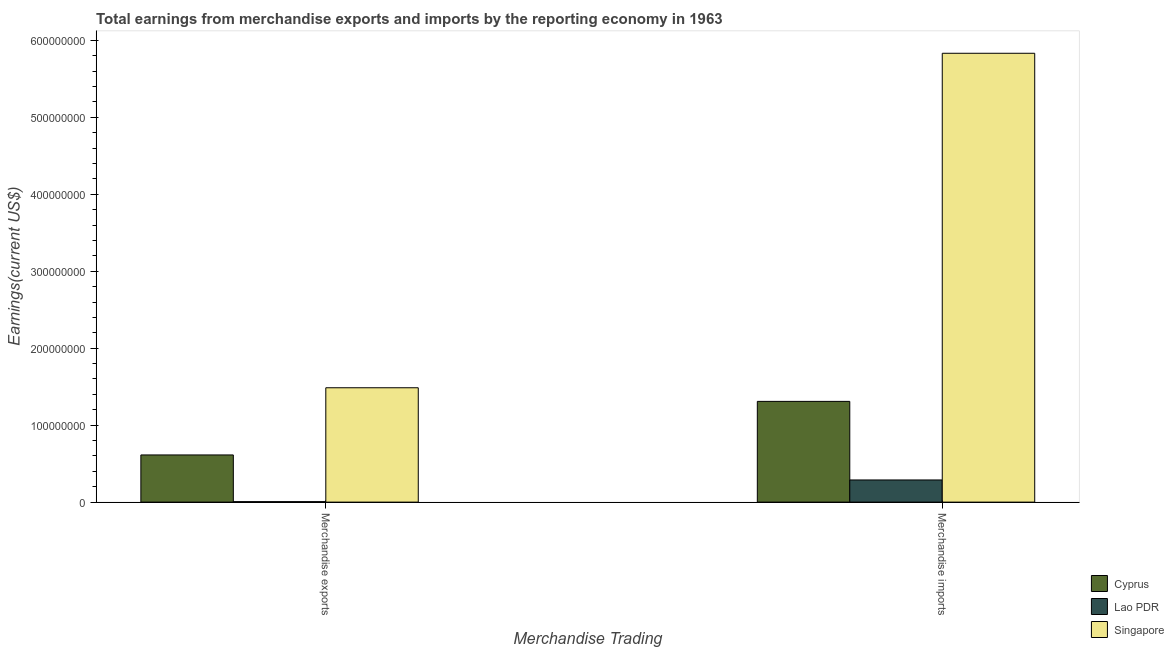How many groups of bars are there?
Provide a short and direct response. 2. How many bars are there on the 2nd tick from the left?
Make the answer very short. 3. What is the earnings from merchandise imports in Lao PDR?
Your answer should be very brief. 2.88e+07. Across all countries, what is the maximum earnings from merchandise exports?
Give a very brief answer. 1.49e+08. Across all countries, what is the minimum earnings from merchandise exports?
Your response must be concise. 5.90e+05. In which country was the earnings from merchandise exports maximum?
Your response must be concise. Singapore. In which country was the earnings from merchandise exports minimum?
Give a very brief answer. Lao PDR. What is the total earnings from merchandise imports in the graph?
Make the answer very short. 7.43e+08. What is the difference between the earnings from merchandise exports in Cyprus and that in Lao PDR?
Offer a very short reply. 6.07e+07. What is the difference between the earnings from merchandise exports in Lao PDR and the earnings from merchandise imports in Singapore?
Your answer should be compact. -5.83e+08. What is the average earnings from merchandise imports per country?
Provide a short and direct response. 2.48e+08. What is the difference between the earnings from merchandise exports and earnings from merchandise imports in Cyprus?
Your answer should be very brief. -6.96e+07. In how many countries, is the earnings from merchandise imports greater than 280000000 US$?
Give a very brief answer. 1. What is the ratio of the earnings from merchandise exports in Lao PDR to that in Singapore?
Offer a very short reply. 0. Is the earnings from merchandise imports in Lao PDR less than that in Singapore?
Give a very brief answer. Yes. In how many countries, is the earnings from merchandise imports greater than the average earnings from merchandise imports taken over all countries?
Offer a terse response. 1. What does the 2nd bar from the left in Merchandise imports represents?
Your answer should be compact. Lao PDR. What does the 2nd bar from the right in Merchandise exports represents?
Make the answer very short. Lao PDR. How many bars are there?
Provide a short and direct response. 6. Are all the bars in the graph horizontal?
Keep it short and to the point. No. What is the difference between two consecutive major ticks on the Y-axis?
Your response must be concise. 1.00e+08. Are the values on the major ticks of Y-axis written in scientific E-notation?
Offer a very short reply. No. Does the graph contain any zero values?
Make the answer very short. No. Does the graph contain grids?
Offer a very short reply. No. Where does the legend appear in the graph?
Your response must be concise. Bottom right. How many legend labels are there?
Your answer should be compact. 3. How are the legend labels stacked?
Provide a short and direct response. Vertical. What is the title of the graph?
Offer a very short reply. Total earnings from merchandise exports and imports by the reporting economy in 1963. Does "Cameroon" appear as one of the legend labels in the graph?
Offer a very short reply. No. What is the label or title of the X-axis?
Make the answer very short. Merchandise Trading. What is the label or title of the Y-axis?
Provide a succinct answer. Earnings(current US$). What is the Earnings(current US$) in Cyprus in Merchandise exports?
Your answer should be very brief. 6.13e+07. What is the Earnings(current US$) in Lao PDR in Merchandise exports?
Your answer should be compact. 5.90e+05. What is the Earnings(current US$) of Singapore in Merchandise exports?
Your response must be concise. 1.49e+08. What is the Earnings(current US$) in Cyprus in Merchandise imports?
Provide a succinct answer. 1.31e+08. What is the Earnings(current US$) in Lao PDR in Merchandise imports?
Keep it short and to the point. 2.88e+07. What is the Earnings(current US$) of Singapore in Merchandise imports?
Give a very brief answer. 5.83e+08. Across all Merchandise Trading, what is the maximum Earnings(current US$) in Cyprus?
Give a very brief answer. 1.31e+08. Across all Merchandise Trading, what is the maximum Earnings(current US$) of Lao PDR?
Provide a short and direct response. 2.88e+07. Across all Merchandise Trading, what is the maximum Earnings(current US$) of Singapore?
Offer a terse response. 5.83e+08. Across all Merchandise Trading, what is the minimum Earnings(current US$) in Cyprus?
Provide a succinct answer. 6.13e+07. Across all Merchandise Trading, what is the minimum Earnings(current US$) in Lao PDR?
Your response must be concise. 5.90e+05. Across all Merchandise Trading, what is the minimum Earnings(current US$) of Singapore?
Make the answer very short. 1.49e+08. What is the total Earnings(current US$) in Cyprus in the graph?
Ensure brevity in your answer.  1.92e+08. What is the total Earnings(current US$) of Lao PDR in the graph?
Give a very brief answer. 2.94e+07. What is the total Earnings(current US$) in Singapore in the graph?
Make the answer very short. 7.32e+08. What is the difference between the Earnings(current US$) of Cyprus in Merchandise exports and that in Merchandise imports?
Provide a succinct answer. -6.96e+07. What is the difference between the Earnings(current US$) of Lao PDR in Merchandise exports and that in Merchandise imports?
Your answer should be very brief. -2.82e+07. What is the difference between the Earnings(current US$) in Singapore in Merchandise exports and that in Merchandise imports?
Your answer should be compact. -4.35e+08. What is the difference between the Earnings(current US$) in Cyprus in Merchandise exports and the Earnings(current US$) in Lao PDR in Merchandise imports?
Ensure brevity in your answer.  3.25e+07. What is the difference between the Earnings(current US$) in Cyprus in Merchandise exports and the Earnings(current US$) in Singapore in Merchandise imports?
Offer a terse response. -5.22e+08. What is the difference between the Earnings(current US$) of Lao PDR in Merchandise exports and the Earnings(current US$) of Singapore in Merchandise imports?
Your answer should be compact. -5.83e+08. What is the average Earnings(current US$) in Cyprus per Merchandise Trading?
Your response must be concise. 9.61e+07. What is the average Earnings(current US$) in Lao PDR per Merchandise Trading?
Your response must be concise. 1.47e+07. What is the average Earnings(current US$) in Singapore per Merchandise Trading?
Keep it short and to the point. 3.66e+08. What is the difference between the Earnings(current US$) in Cyprus and Earnings(current US$) in Lao PDR in Merchandise exports?
Offer a terse response. 6.07e+07. What is the difference between the Earnings(current US$) of Cyprus and Earnings(current US$) of Singapore in Merchandise exports?
Provide a succinct answer. -8.73e+07. What is the difference between the Earnings(current US$) in Lao PDR and Earnings(current US$) in Singapore in Merchandise exports?
Make the answer very short. -1.48e+08. What is the difference between the Earnings(current US$) of Cyprus and Earnings(current US$) of Lao PDR in Merchandise imports?
Provide a short and direct response. 1.02e+08. What is the difference between the Earnings(current US$) in Cyprus and Earnings(current US$) in Singapore in Merchandise imports?
Ensure brevity in your answer.  -4.52e+08. What is the difference between the Earnings(current US$) of Lao PDR and Earnings(current US$) of Singapore in Merchandise imports?
Your answer should be very brief. -5.54e+08. What is the ratio of the Earnings(current US$) in Cyprus in Merchandise exports to that in Merchandise imports?
Offer a terse response. 0.47. What is the ratio of the Earnings(current US$) in Lao PDR in Merchandise exports to that in Merchandise imports?
Provide a succinct answer. 0.02. What is the ratio of the Earnings(current US$) in Singapore in Merchandise exports to that in Merchandise imports?
Your answer should be very brief. 0.25. What is the difference between the highest and the second highest Earnings(current US$) in Cyprus?
Make the answer very short. 6.96e+07. What is the difference between the highest and the second highest Earnings(current US$) of Lao PDR?
Offer a very short reply. 2.82e+07. What is the difference between the highest and the second highest Earnings(current US$) of Singapore?
Your answer should be compact. 4.35e+08. What is the difference between the highest and the lowest Earnings(current US$) of Cyprus?
Ensure brevity in your answer.  6.96e+07. What is the difference between the highest and the lowest Earnings(current US$) in Lao PDR?
Your response must be concise. 2.82e+07. What is the difference between the highest and the lowest Earnings(current US$) in Singapore?
Ensure brevity in your answer.  4.35e+08. 